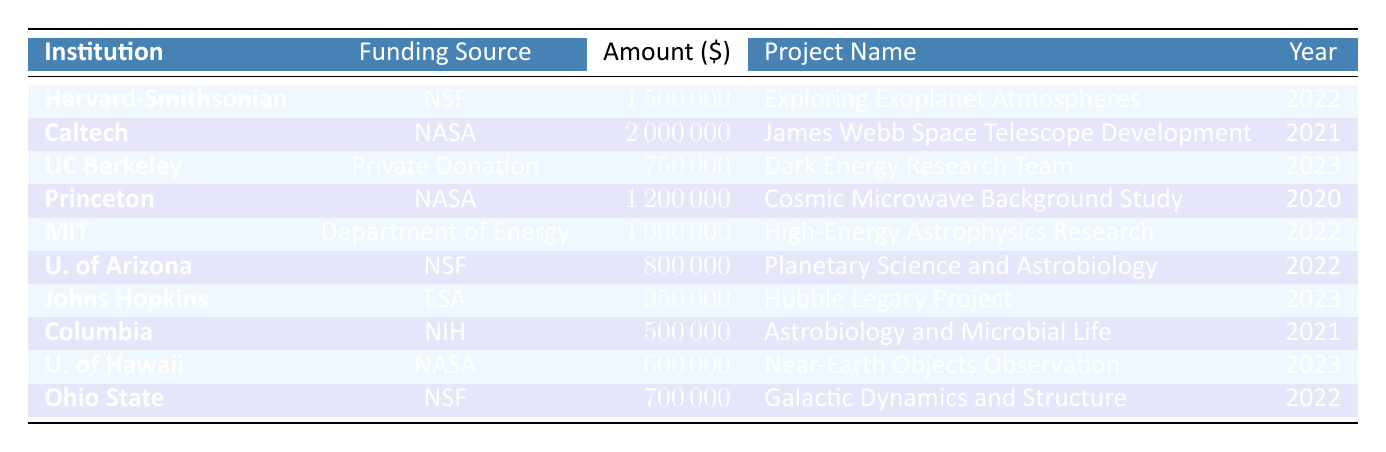What is the total funding amount awarded to Harvard-Smithsonian Center for Astrophysics? The table shows that Harvard-Smithsonian Center for Astrophysics received a funding amount of 1,500,000 from the National Science Foundation for the project "Exploring Exoplanet Atmospheres" in 2022.
Answer: 1,500,000 Which institution received funding from the European Space Agency? The table lists Johns Hopkins University as the institution that received funding from the European Space Agency for the project "Hubble Legacy Project" in 2023.
Answer: Johns Hopkins University What is the funding amount for the project "James Webb Space Telescope Development"? According to the table, the funding amount for the project "James Webb Space Telescope Development" is 2,000,000, awarded to the California Institute of Technology by NASA in 2021.
Answer: 2,000,000 How many projects received funding from the National Science Foundation? The table shows three projects that received funding from the National Science Foundation: Harvard-Smithsonian Center for Astrophysics, University of Arizona, and Ohio State University.
Answer: 3 Which project received the least funding and from which institution? The project that received the least funding is "Astrobiology and Microbial Life" with an amount of 500,000 and was awarded to Columbia University from the National Institutes of Health in 2021.
Answer: Astrobiology and Microbial Life at Columbia University What is the total amount of funding from NASA listed in the table? The projects listed in the table that received funding from NASA are: "James Webb Space Telescope Development" with 2,000,000 and "Cosmic Microwave Background Study" with 1,200,000 and "Observational Programs for Near-Earth Objects" with 600,000. The sum of these amounts is 2,000,000 + 1,200,000 + 600,000 = 3,800,000.
Answer: 3,800,000 Which institution had the highest funding amount, and what project was it for? The highest funding amount is 2,000,000 awarded to the California Institute of Technology for the project "James Webb Space Telescope Development" in 2021.
Answer: California Institute of Technology for James Webb Space Telescope Development Is there any project funded in 2020? Yes, there is one project funded in 2020, which is "Cosmic Microwave Background Study" at Princeton University for the amount of 1,200,000.
Answer: Yes How does the funding of University of Hawaii compare to the funding of University of California, Berkeley? University of Hawaii received 600,000 for "Observational Programs for Near-Earth Objects" in 2023, while University of California, Berkeley received 750,000 for "Dark Energy Research Team" in 2023. The comparison shows that UC Berkeley received 150,000 more than University of Hawaii.
Answer: UC Berkeley received more by 150,000 What percentage of the total funding went to projects in 2022? The total funding amounts in 2022 are: Harvard-Smithsonian Center for Astrophysics (1,500,000), Massachusetts Institute of Technology (1,000,000), University of Arizona (800,000), and Ohio State University (700,000). Summing these gives 1,500,000 + 1,000,000 + 800,000 + 700,000 = 4,000,000. The overall total funding amount for all years is 1500000 + 2000000 + 750000 + 1200000 + 1000000 + 800000 + 950000 + 500000 + 600000 + 700000 = 9,850,000. The percentage for 2022 is (4,000,000 / 9,850,000) * 100 ≈ 40.5%.
Answer: 40.5% 